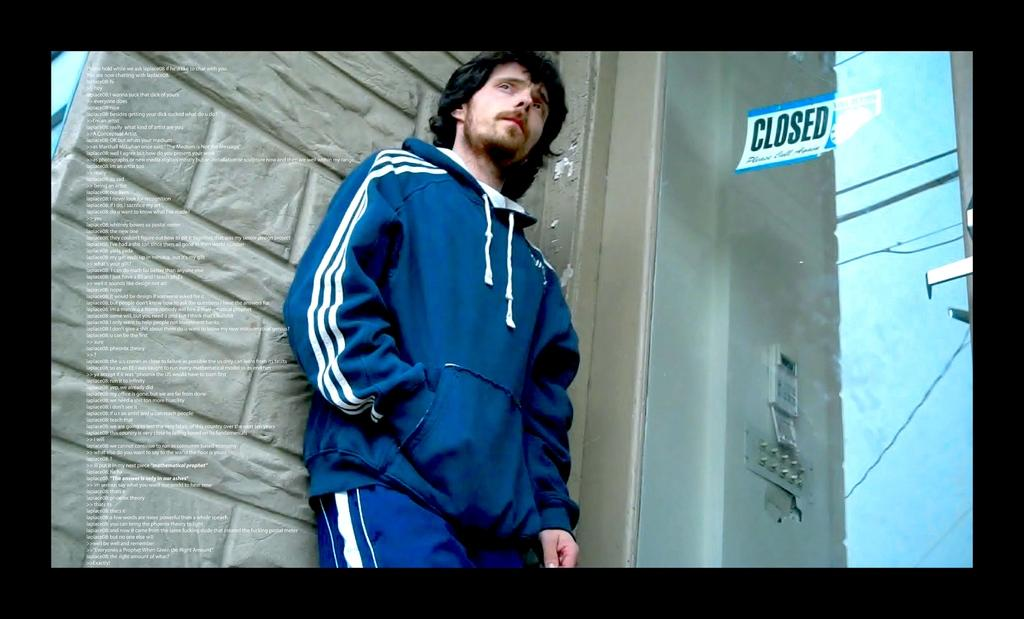<image>
Write a terse but informative summary of the picture. Man standing in front of a building that says "Closed". 